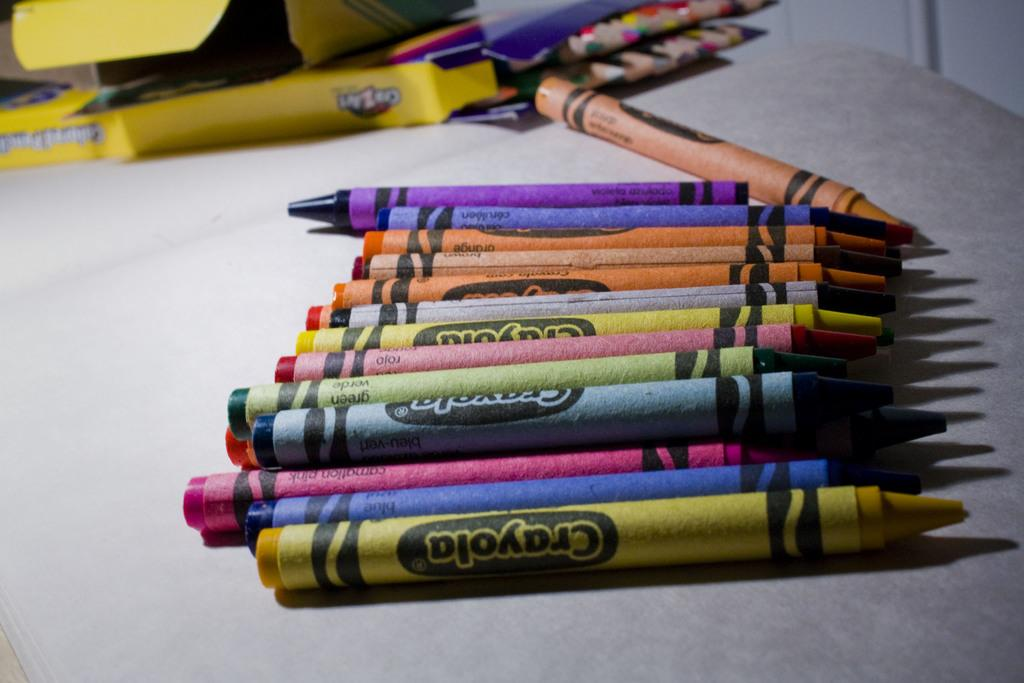<image>
Write a terse but informative summary of the picture. Several different crayons laid out, one is carnation pink. 